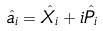<formula> <loc_0><loc_0><loc_500><loc_500>\hat { a _ { i } } = \hat { X _ { i } } + i \hat { P _ { i } }</formula> 